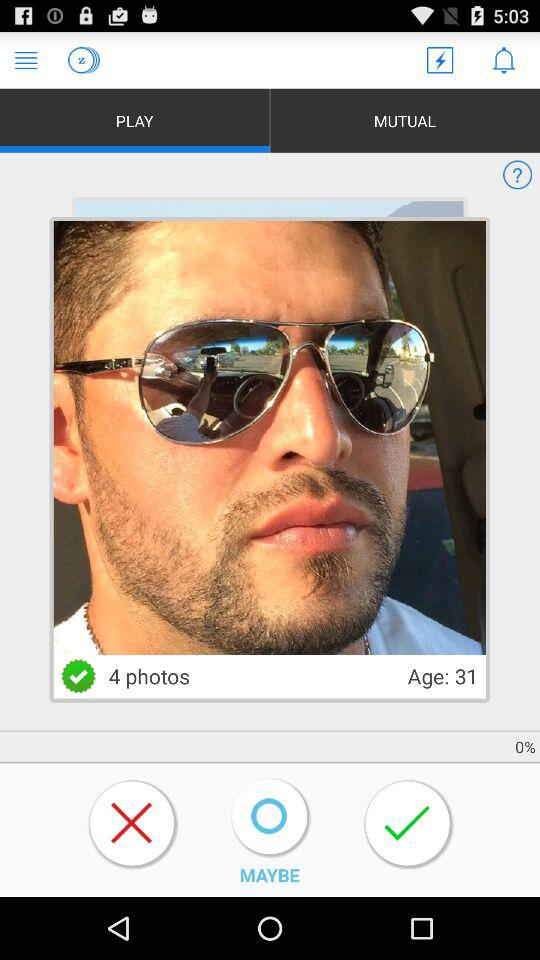How many photos are there?
Answer the question using a single word or phrase. 4 